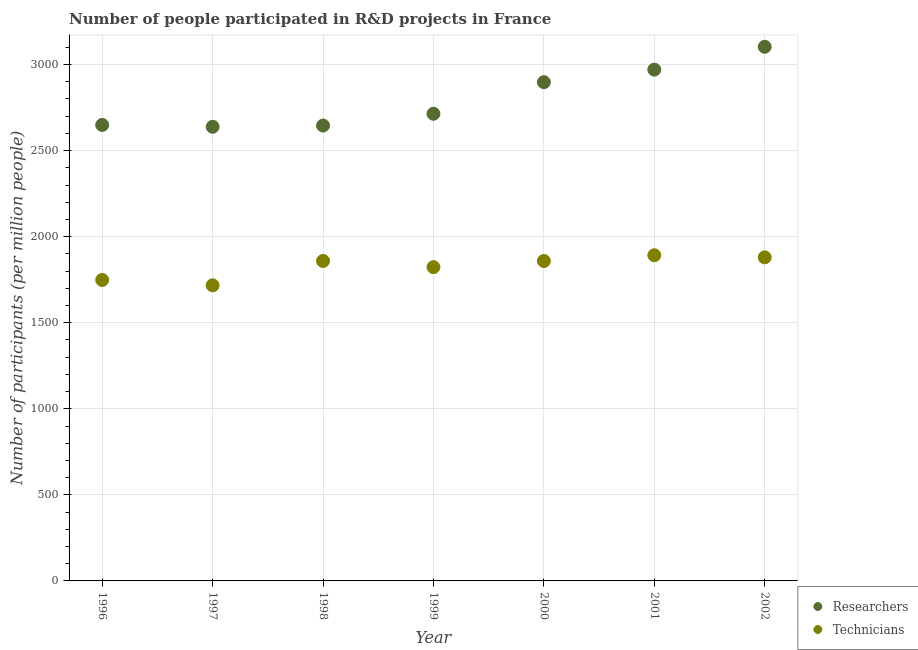Is the number of dotlines equal to the number of legend labels?
Provide a succinct answer. Yes. What is the number of technicians in 2002?
Make the answer very short. 1879.95. Across all years, what is the maximum number of researchers?
Ensure brevity in your answer.  3103.08. Across all years, what is the minimum number of researchers?
Keep it short and to the point. 2638.28. In which year was the number of researchers maximum?
Your answer should be very brief. 2002. What is the total number of technicians in the graph?
Keep it short and to the point. 1.28e+04. What is the difference between the number of technicians in 2001 and that in 2002?
Your response must be concise. 12.09. What is the difference between the number of researchers in 1998 and the number of technicians in 1996?
Your answer should be very brief. 896.82. What is the average number of researchers per year?
Keep it short and to the point. 2802.56. In the year 2000, what is the difference between the number of technicians and number of researchers?
Your answer should be very brief. -1038.78. In how many years, is the number of technicians greater than 400?
Your response must be concise. 7. What is the ratio of the number of researchers in 1996 to that in 2001?
Keep it short and to the point. 0.89. Is the difference between the number of researchers in 1996 and 2000 greater than the difference between the number of technicians in 1996 and 2000?
Ensure brevity in your answer.  No. What is the difference between the highest and the second highest number of technicians?
Keep it short and to the point. 12.09. What is the difference between the highest and the lowest number of technicians?
Make the answer very short. 174.72. In how many years, is the number of technicians greater than the average number of technicians taken over all years?
Ensure brevity in your answer.  4. Is the sum of the number of researchers in 1997 and 2002 greater than the maximum number of technicians across all years?
Give a very brief answer. Yes. Is the number of technicians strictly less than the number of researchers over the years?
Your response must be concise. Yes. How many years are there in the graph?
Your response must be concise. 7. What is the difference between two consecutive major ticks on the Y-axis?
Keep it short and to the point. 500. Does the graph contain grids?
Offer a very short reply. Yes. How are the legend labels stacked?
Your answer should be very brief. Vertical. What is the title of the graph?
Ensure brevity in your answer.  Number of people participated in R&D projects in France. Does "Taxes on exports" appear as one of the legend labels in the graph?
Your response must be concise. No. What is the label or title of the X-axis?
Your answer should be compact. Year. What is the label or title of the Y-axis?
Your answer should be compact. Number of participants (per million people). What is the Number of participants (per million people) of Researchers in 1996?
Your answer should be very brief. 2649.18. What is the Number of participants (per million people) in Technicians in 1996?
Offer a terse response. 1748.56. What is the Number of participants (per million people) of Researchers in 1997?
Keep it short and to the point. 2638.28. What is the Number of participants (per million people) of Technicians in 1997?
Your answer should be very brief. 1717.32. What is the Number of participants (per million people) of Researchers in 1998?
Make the answer very short. 2645.38. What is the Number of participants (per million people) in Technicians in 1998?
Provide a short and direct response. 1858.87. What is the Number of participants (per million people) of Researchers in 1999?
Offer a very short reply. 2714.09. What is the Number of participants (per million people) of Technicians in 1999?
Make the answer very short. 1823. What is the Number of participants (per million people) of Researchers in 2000?
Offer a very short reply. 2897.43. What is the Number of participants (per million people) in Technicians in 2000?
Offer a terse response. 1858.64. What is the Number of participants (per million people) of Researchers in 2001?
Ensure brevity in your answer.  2970.46. What is the Number of participants (per million people) of Technicians in 2001?
Offer a very short reply. 1892.04. What is the Number of participants (per million people) of Researchers in 2002?
Keep it short and to the point. 3103.08. What is the Number of participants (per million people) of Technicians in 2002?
Make the answer very short. 1879.95. Across all years, what is the maximum Number of participants (per million people) in Researchers?
Provide a succinct answer. 3103.08. Across all years, what is the maximum Number of participants (per million people) in Technicians?
Provide a succinct answer. 1892.04. Across all years, what is the minimum Number of participants (per million people) of Researchers?
Offer a very short reply. 2638.28. Across all years, what is the minimum Number of participants (per million people) of Technicians?
Give a very brief answer. 1717.32. What is the total Number of participants (per million people) in Researchers in the graph?
Your response must be concise. 1.96e+04. What is the total Number of participants (per million people) in Technicians in the graph?
Your answer should be very brief. 1.28e+04. What is the difference between the Number of participants (per million people) in Technicians in 1996 and that in 1997?
Make the answer very short. 31.25. What is the difference between the Number of participants (per million people) in Researchers in 1996 and that in 1998?
Your response must be concise. 3.8. What is the difference between the Number of participants (per million people) in Technicians in 1996 and that in 1998?
Ensure brevity in your answer.  -110.3. What is the difference between the Number of participants (per million people) of Researchers in 1996 and that in 1999?
Ensure brevity in your answer.  -64.91. What is the difference between the Number of participants (per million people) in Technicians in 1996 and that in 1999?
Your answer should be compact. -74.44. What is the difference between the Number of participants (per million people) in Researchers in 1996 and that in 2000?
Provide a succinct answer. -248.24. What is the difference between the Number of participants (per million people) in Technicians in 1996 and that in 2000?
Your answer should be very brief. -110.08. What is the difference between the Number of participants (per million people) in Researchers in 1996 and that in 2001?
Your answer should be very brief. -321.28. What is the difference between the Number of participants (per million people) in Technicians in 1996 and that in 2001?
Offer a terse response. -143.48. What is the difference between the Number of participants (per million people) of Researchers in 1996 and that in 2002?
Offer a terse response. -453.9. What is the difference between the Number of participants (per million people) in Technicians in 1996 and that in 2002?
Your answer should be compact. -131.38. What is the difference between the Number of participants (per million people) of Researchers in 1997 and that in 1998?
Your answer should be compact. -7.1. What is the difference between the Number of participants (per million people) of Technicians in 1997 and that in 1998?
Keep it short and to the point. -141.55. What is the difference between the Number of participants (per million people) in Researchers in 1997 and that in 1999?
Make the answer very short. -75.81. What is the difference between the Number of participants (per million people) of Technicians in 1997 and that in 1999?
Keep it short and to the point. -105.69. What is the difference between the Number of participants (per million people) in Researchers in 1997 and that in 2000?
Your answer should be compact. -259.14. What is the difference between the Number of participants (per million people) in Technicians in 1997 and that in 2000?
Your answer should be very brief. -141.33. What is the difference between the Number of participants (per million people) in Researchers in 1997 and that in 2001?
Keep it short and to the point. -332.18. What is the difference between the Number of participants (per million people) in Technicians in 1997 and that in 2001?
Provide a short and direct response. -174.72. What is the difference between the Number of participants (per million people) in Researchers in 1997 and that in 2002?
Give a very brief answer. -464.8. What is the difference between the Number of participants (per million people) of Technicians in 1997 and that in 2002?
Ensure brevity in your answer.  -162.63. What is the difference between the Number of participants (per million people) in Researchers in 1998 and that in 1999?
Your answer should be very brief. -68.71. What is the difference between the Number of participants (per million people) of Technicians in 1998 and that in 1999?
Keep it short and to the point. 35.86. What is the difference between the Number of participants (per million people) in Researchers in 1998 and that in 2000?
Keep it short and to the point. -252.04. What is the difference between the Number of participants (per million people) of Technicians in 1998 and that in 2000?
Your answer should be very brief. 0.22. What is the difference between the Number of participants (per million people) in Researchers in 1998 and that in 2001?
Your response must be concise. -325.08. What is the difference between the Number of participants (per million people) of Technicians in 1998 and that in 2001?
Keep it short and to the point. -33.17. What is the difference between the Number of participants (per million people) of Researchers in 1998 and that in 2002?
Provide a short and direct response. -457.7. What is the difference between the Number of participants (per million people) in Technicians in 1998 and that in 2002?
Give a very brief answer. -21.08. What is the difference between the Number of participants (per million people) of Researchers in 1999 and that in 2000?
Your answer should be compact. -183.33. What is the difference between the Number of participants (per million people) of Technicians in 1999 and that in 2000?
Your response must be concise. -35.64. What is the difference between the Number of participants (per million people) of Researchers in 1999 and that in 2001?
Make the answer very short. -256.37. What is the difference between the Number of participants (per million people) in Technicians in 1999 and that in 2001?
Provide a short and direct response. -69.04. What is the difference between the Number of participants (per million people) in Researchers in 1999 and that in 2002?
Your answer should be compact. -388.99. What is the difference between the Number of participants (per million people) in Technicians in 1999 and that in 2002?
Give a very brief answer. -56.94. What is the difference between the Number of participants (per million people) in Researchers in 2000 and that in 2001?
Your response must be concise. -73.04. What is the difference between the Number of participants (per million people) in Technicians in 2000 and that in 2001?
Provide a succinct answer. -33.4. What is the difference between the Number of participants (per million people) in Researchers in 2000 and that in 2002?
Keep it short and to the point. -205.65. What is the difference between the Number of participants (per million people) of Technicians in 2000 and that in 2002?
Your answer should be compact. -21.3. What is the difference between the Number of participants (per million people) in Researchers in 2001 and that in 2002?
Offer a terse response. -132.62. What is the difference between the Number of participants (per million people) of Technicians in 2001 and that in 2002?
Give a very brief answer. 12.09. What is the difference between the Number of participants (per million people) of Researchers in 1996 and the Number of participants (per million people) of Technicians in 1997?
Your answer should be very brief. 931.87. What is the difference between the Number of participants (per million people) in Researchers in 1996 and the Number of participants (per million people) in Technicians in 1998?
Provide a succinct answer. 790.32. What is the difference between the Number of participants (per million people) of Researchers in 1996 and the Number of participants (per million people) of Technicians in 1999?
Your answer should be very brief. 826.18. What is the difference between the Number of participants (per million people) in Researchers in 1996 and the Number of participants (per million people) in Technicians in 2000?
Offer a terse response. 790.54. What is the difference between the Number of participants (per million people) of Researchers in 1996 and the Number of participants (per million people) of Technicians in 2001?
Give a very brief answer. 757.14. What is the difference between the Number of participants (per million people) in Researchers in 1996 and the Number of participants (per million people) in Technicians in 2002?
Make the answer very short. 769.24. What is the difference between the Number of participants (per million people) of Researchers in 1997 and the Number of participants (per million people) of Technicians in 1998?
Offer a very short reply. 779.42. What is the difference between the Number of participants (per million people) in Researchers in 1997 and the Number of participants (per million people) in Technicians in 1999?
Keep it short and to the point. 815.28. What is the difference between the Number of participants (per million people) in Researchers in 1997 and the Number of participants (per million people) in Technicians in 2000?
Offer a terse response. 779.64. What is the difference between the Number of participants (per million people) in Researchers in 1997 and the Number of participants (per million people) in Technicians in 2001?
Offer a terse response. 746.24. What is the difference between the Number of participants (per million people) in Researchers in 1997 and the Number of participants (per million people) in Technicians in 2002?
Your answer should be compact. 758.34. What is the difference between the Number of participants (per million people) in Researchers in 1998 and the Number of participants (per million people) in Technicians in 1999?
Your answer should be compact. 822.38. What is the difference between the Number of participants (per million people) in Researchers in 1998 and the Number of participants (per million people) in Technicians in 2000?
Your answer should be very brief. 786.74. What is the difference between the Number of participants (per million people) of Researchers in 1998 and the Number of participants (per million people) of Technicians in 2001?
Your response must be concise. 753.34. What is the difference between the Number of participants (per million people) in Researchers in 1998 and the Number of participants (per million people) in Technicians in 2002?
Your answer should be compact. 765.44. What is the difference between the Number of participants (per million people) of Researchers in 1999 and the Number of participants (per million people) of Technicians in 2000?
Offer a very short reply. 855.45. What is the difference between the Number of participants (per million people) in Researchers in 1999 and the Number of participants (per million people) in Technicians in 2001?
Ensure brevity in your answer.  822.05. What is the difference between the Number of participants (per million people) of Researchers in 1999 and the Number of participants (per million people) of Technicians in 2002?
Offer a terse response. 834.15. What is the difference between the Number of participants (per million people) of Researchers in 2000 and the Number of participants (per million people) of Technicians in 2001?
Keep it short and to the point. 1005.39. What is the difference between the Number of participants (per million people) of Researchers in 2000 and the Number of participants (per million people) of Technicians in 2002?
Provide a succinct answer. 1017.48. What is the difference between the Number of participants (per million people) of Researchers in 2001 and the Number of participants (per million people) of Technicians in 2002?
Provide a succinct answer. 1090.52. What is the average Number of participants (per million people) of Researchers per year?
Ensure brevity in your answer.  2802.56. What is the average Number of participants (per million people) of Technicians per year?
Your answer should be compact. 1825.48. In the year 1996, what is the difference between the Number of participants (per million people) of Researchers and Number of participants (per million people) of Technicians?
Give a very brief answer. 900.62. In the year 1997, what is the difference between the Number of participants (per million people) of Researchers and Number of participants (per million people) of Technicians?
Ensure brevity in your answer.  920.97. In the year 1998, what is the difference between the Number of participants (per million people) of Researchers and Number of participants (per million people) of Technicians?
Your answer should be compact. 786.52. In the year 1999, what is the difference between the Number of participants (per million people) of Researchers and Number of participants (per million people) of Technicians?
Provide a succinct answer. 891.09. In the year 2000, what is the difference between the Number of participants (per million people) in Researchers and Number of participants (per million people) in Technicians?
Provide a short and direct response. 1038.78. In the year 2001, what is the difference between the Number of participants (per million people) in Researchers and Number of participants (per million people) in Technicians?
Ensure brevity in your answer.  1078.42. In the year 2002, what is the difference between the Number of participants (per million people) in Researchers and Number of participants (per million people) in Technicians?
Give a very brief answer. 1223.13. What is the ratio of the Number of participants (per million people) of Technicians in 1996 to that in 1997?
Provide a short and direct response. 1.02. What is the ratio of the Number of participants (per million people) in Technicians in 1996 to that in 1998?
Keep it short and to the point. 0.94. What is the ratio of the Number of participants (per million people) in Researchers in 1996 to that in 1999?
Your answer should be very brief. 0.98. What is the ratio of the Number of participants (per million people) in Technicians in 1996 to that in 1999?
Keep it short and to the point. 0.96. What is the ratio of the Number of participants (per million people) in Researchers in 1996 to that in 2000?
Your answer should be compact. 0.91. What is the ratio of the Number of participants (per million people) in Technicians in 1996 to that in 2000?
Give a very brief answer. 0.94. What is the ratio of the Number of participants (per million people) of Researchers in 1996 to that in 2001?
Give a very brief answer. 0.89. What is the ratio of the Number of participants (per million people) in Technicians in 1996 to that in 2001?
Provide a short and direct response. 0.92. What is the ratio of the Number of participants (per million people) in Researchers in 1996 to that in 2002?
Provide a short and direct response. 0.85. What is the ratio of the Number of participants (per million people) in Technicians in 1996 to that in 2002?
Keep it short and to the point. 0.93. What is the ratio of the Number of participants (per million people) of Technicians in 1997 to that in 1998?
Your response must be concise. 0.92. What is the ratio of the Number of participants (per million people) in Researchers in 1997 to that in 1999?
Provide a succinct answer. 0.97. What is the ratio of the Number of participants (per million people) of Technicians in 1997 to that in 1999?
Provide a short and direct response. 0.94. What is the ratio of the Number of participants (per million people) of Researchers in 1997 to that in 2000?
Offer a terse response. 0.91. What is the ratio of the Number of participants (per million people) in Technicians in 1997 to that in 2000?
Your response must be concise. 0.92. What is the ratio of the Number of participants (per million people) in Researchers in 1997 to that in 2001?
Your response must be concise. 0.89. What is the ratio of the Number of participants (per million people) in Technicians in 1997 to that in 2001?
Offer a very short reply. 0.91. What is the ratio of the Number of participants (per million people) in Researchers in 1997 to that in 2002?
Make the answer very short. 0.85. What is the ratio of the Number of participants (per million people) in Technicians in 1997 to that in 2002?
Your answer should be very brief. 0.91. What is the ratio of the Number of participants (per million people) in Researchers in 1998 to that in 1999?
Give a very brief answer. 0.97. What is the ratio of the Number of participants (per million people) of Technicians in 1998 to that in 1999?
Ensure brevity in your answer.  1.02. What is the ratio of the Number of participants (per million people) in Technicians in 1998 to that in 2000?
Provide a succinct answer. 1. What is the ratio of the Number of participants (per million people) in Researchers in 1998 to that in 2001?
Give a very brief answer. 0.89. What is the ratio of the Number of participants (per million people) in Technicians in 1998 to that in 2001?
Provide a short and direct response. 0.98. What is the ratio of the Number of participants (per million people) of Researchers in 1998 to that in 2002?
Make the answer very short. 0.85. What is the ratio of the Number of participants (per million people) of Technicians in 1998 to that in 2002?
Your response must be concise. 0.99. What is the ratio of the Number of participants (per million people) in Researchers in 1999 to that in 2000?
Make the answer very short. 0.94. What is the ratio of the Number of participants (per million people) of Technicians in 1999 to that in 2000?
Offer a very short reply. 0.98. What is the ratio of the Number of participants (per million people) in Researchers in 1999 to that in 2001?
Make the answer very short. 0.91. What is the ratio of the Number of participants (per million people) in Technicians in 1999 to that in 2001?
Provide a short and direct response. 0.96. What is the ratio of the Number of participants (per million people) of Researchers in 1999 to that in 2002?
Offer a terse response. 0.87. What is the ratio of the Number of participants (per million people) in Technicians in 1999 to that in 2002?
Offer a terse response. 0.97. What is the ratio of the Number of participants (per million people) of Researchers in 2000 to that in 2001?
Offer a terse response. 0.98. What is the ratio of the Number of participants (per million people) of Technicians in 2000 to that in 2001?
Offer a terse response. 0.98. What is the ratio of the Number of participants (per million people) of Researchers in 2000 to that in 2002?
Your response must be concise. 0.93. What is the ratio of the Number of participants (per million people) of Technicians in 2000 to that in 2002?
Keep it short and to the point. 0.99. What is the ratio of the Number of participants (per million people) of Researchers in 2001 to that in 2002?
Your answer should be very brief. 0.96. What is the ratio of the Number of participants (per million people) of Technicians in 2001 to that in 2002?
Offer a very short reply. 1.01. What is the difference between the highest and the second highest Number of participants (per million people) in Researchers?
Offer a very short reply. 132.62. What is the difference between the highest and the second highest Number of participants (per million people) in Technicians?
Give a very brief answer. 12.09. What is the difference between the highest and the lowest Number of participants (per million people) of Researchers?
Make the answer very short. 464.8. What is the difference between the highest and the lowest Number of participants (per million people) of Technicians?
Keep it short and to the point. 174.72. 